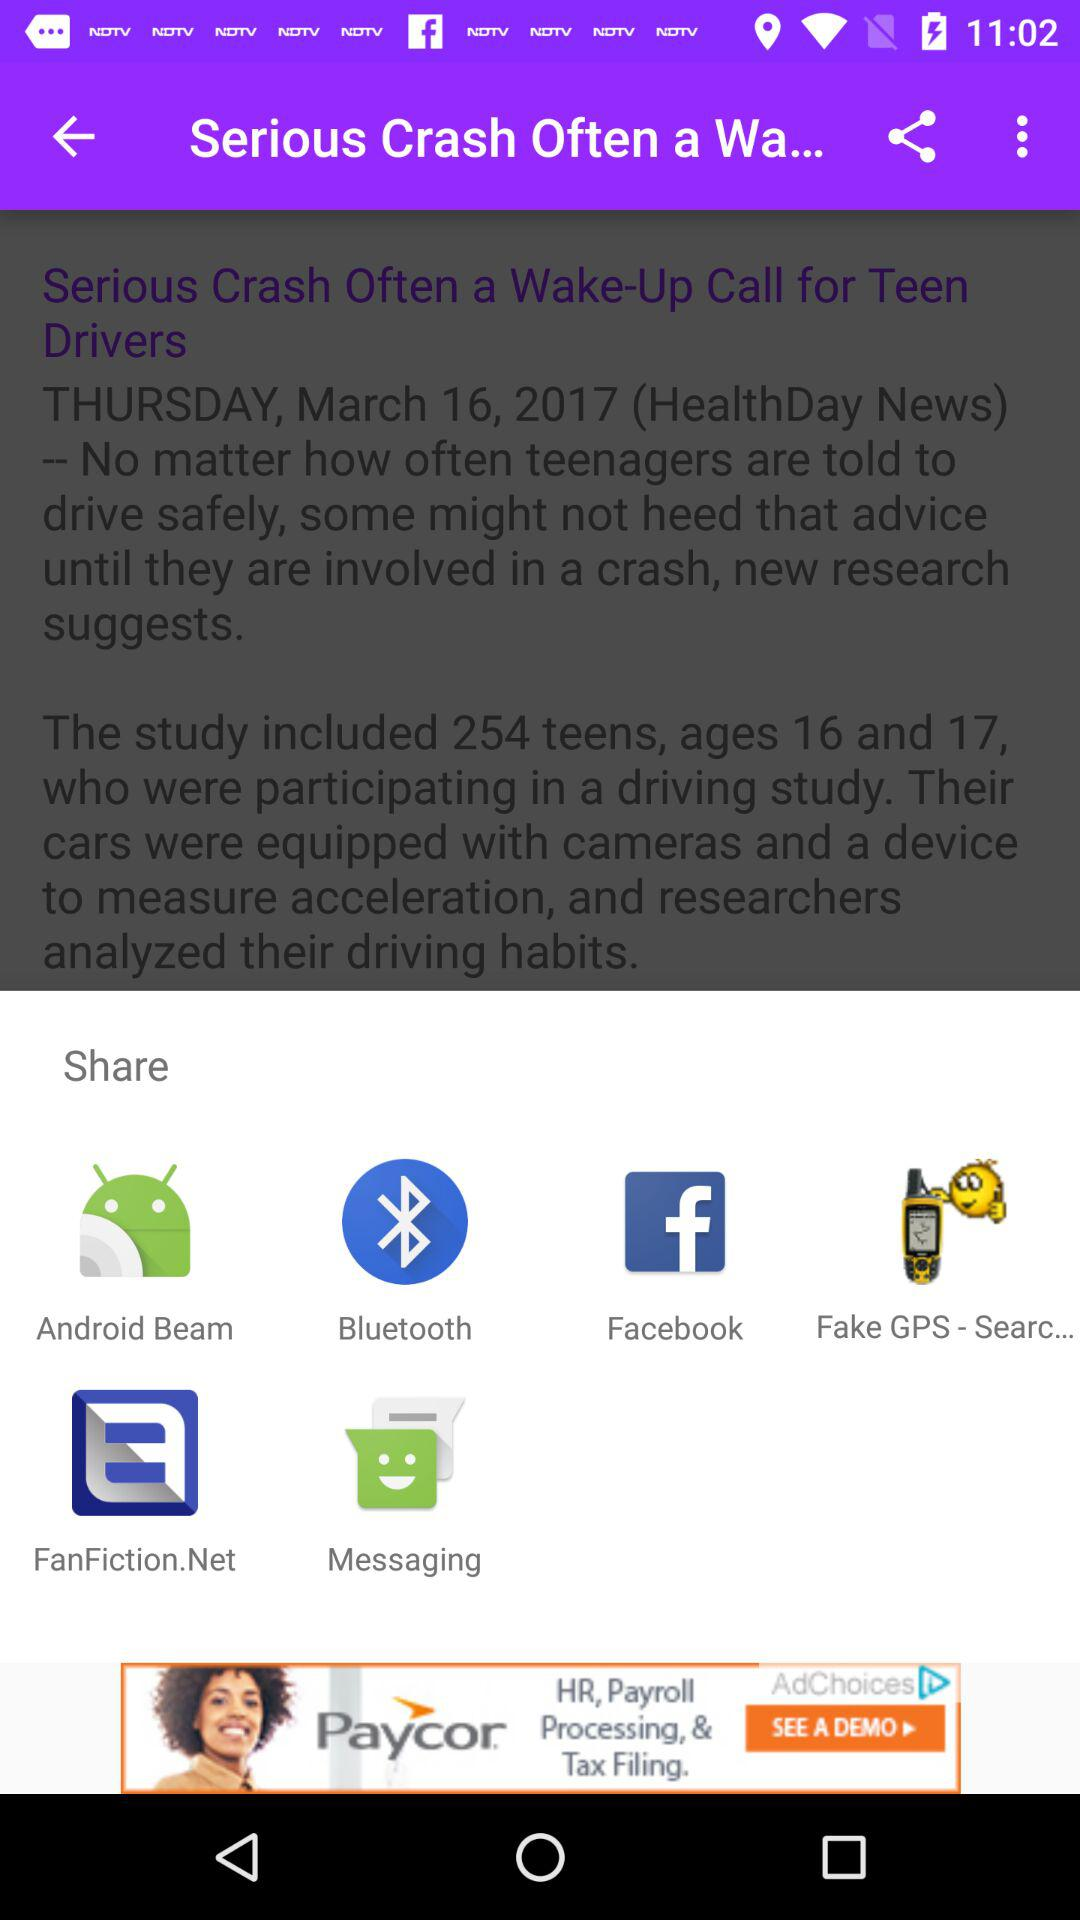Which are the different sharing options? The different sharing options are "Android Beam", "Bluetooth", "Facebook", "Fake GPS - Searc...", "FanFiction.Net" and "Messaging". 